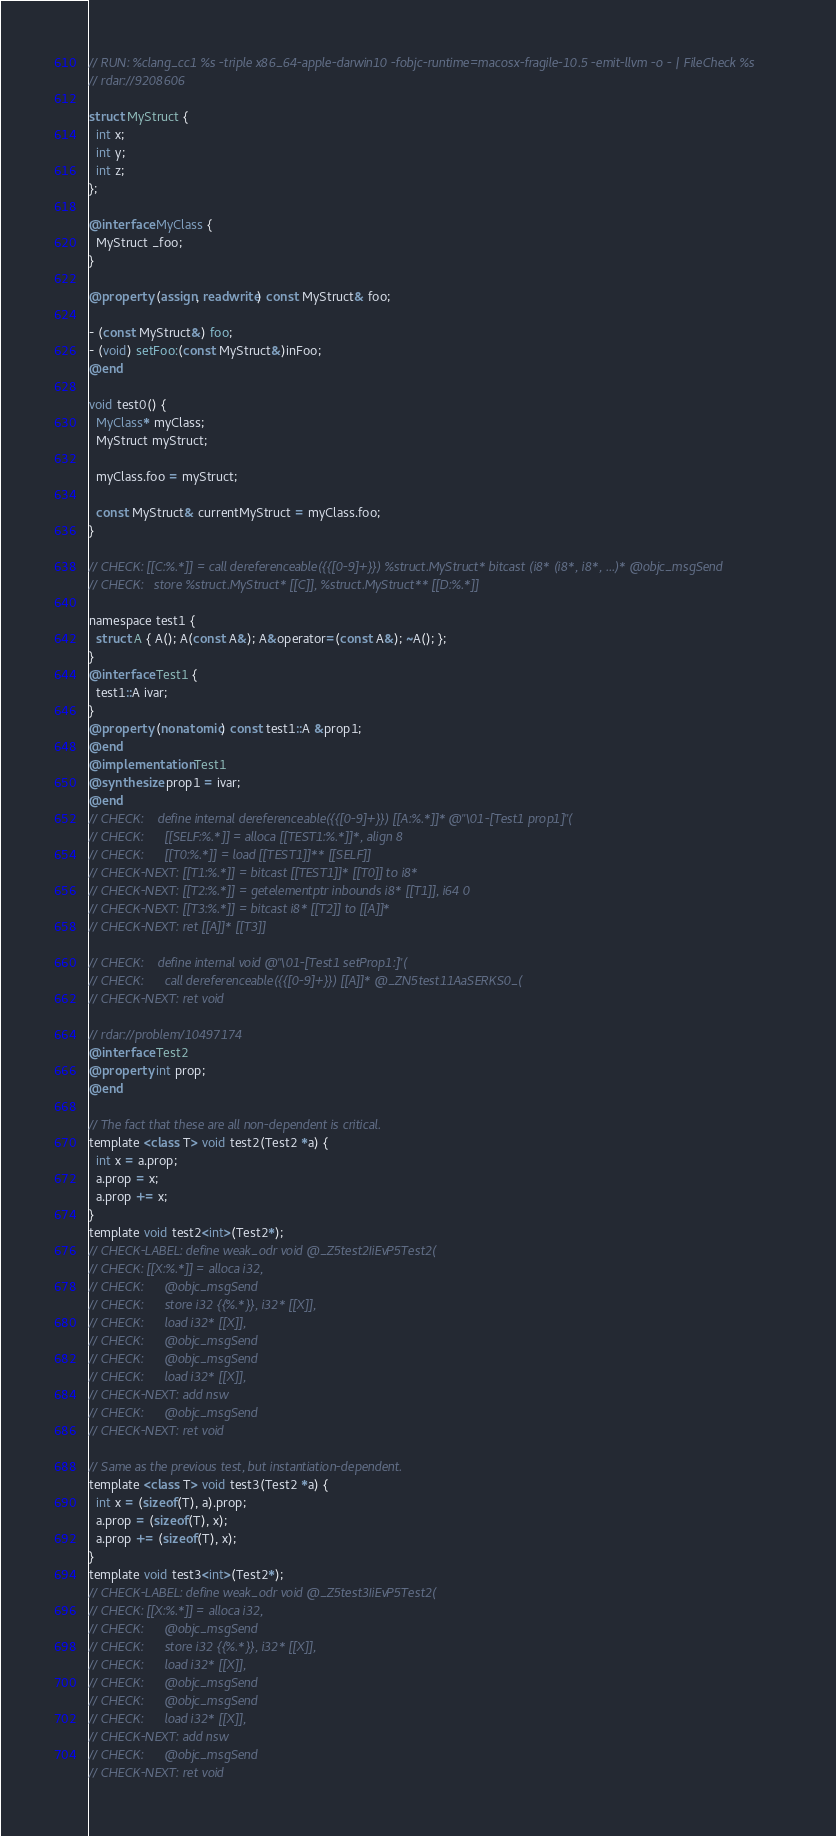<code> <loc_0><loc_0><loc_500><loc_500><_ObjectiveC_>// RUN: %clang_cc1 %s -triple x86_64-apple-darwin10 -fobjc-runtime=macosx-fragile-10.5 -emit-llvm -o - | FileCheck %s
// rdar://9208606

struct MyStruct {
  int x;
  int y;
  int z;
};

@interface MyClass {
  MyStruct _foo;
}

@property (assign, readwrite) const MyStruct& foo;

- (const MyStruct&) foo;
- (void) setFoo:(const MyStruct&)inFoo;
@end

void test0() {
  MyClass* myClass;
  MyStruct myStruct;

  myClass.foo = myStruct;

  const MyStruct& currentMyStruct = myClass.foo;   
}

// CHECK: [[C:%.*]] = call dereferenceable({{[0-9]+}}) %struct.MyStruct* bitcast (i8* (i8*, i8*, ...)* @objc_msgSend
// CHECK:   store %struct.MyStruct* [[C]], %struct.MyStruct** [[D:%.*]]

namespace test1 {
  struct A { A(); A(const A&); A&operator=(const A&); ~A(); };
}
@interface Test1 {
  test1::A ivar;
}
@property (nonatomic) const test1::A &prop1;
@end
@implementation Test1
@synthesize prop1 = ivar;
@end
// CHECK:    define internal dereferenceable({{[0-9]+}}) [[A:%.*]]* @"\01-[Test1 prop1]"(
// CHECK:      [[SELF:%.*]] = alloca [[TEST1:%.*]]*, align 8
// CHECK:      [[T0:%.*]] = load [[TEST1]]** [[SELF]]
// CHECK-NEXT: [[T1:%.*]] = bitcast [[TEST1]]* [[T0]] to i8*
// CHECK-NEXT: [[T2:%.*]] = getelementptr inbounds i8* [[T1]], i64 0
// CHECK-NEXT: [[T3:%.*]] = bitcast i8* [[T2]] to [[A]]*
// CHECK-NEXT: ret [[A]]* [[T3]]

// CHECK:    define internal void @"\01-[Test1 setProp1:]"(
// CHECK:      call dereferenceable({{[0-9]+}}) [[A]]* @_ZN5test11AaSERKS0_(
// CHECK-NEXT: ret void

// rdar://problem/10497174
@interface Test2
@property int prop;
@end

// The fact that these are all non-dependent is critical.
template <class T> void test2(Test2 *a) {
  int x = a.prop;
  a.prop = x;
  a.prop += x;
}
template void test2<int>(Test2*);
// CHECK-LABEL: define weak_odr void @_Z5test2IiEvP5Test2(
// CHECK: [[X:%.*]] = alloca i32,
// CHECK:      @objc_msgSend
// CHECK:      store i32 {{%.*}}, i32* [[X]],
// CHECK:      load i32* [[X]],
// CHECK:      @objc_msgSend
// CHECK:      @objc_msgSend
// CHECK:      load i32* [[X]],
// CHECK-NEXT: add nsw
// CHECK:      @objc_msgSend
// CHECK-NEXT: ret void

// Same as the previous test, but instantiation-dependent.
template <class T> void test3(Test2 *a) {
  int x = (sizeof(T), a).prop;
  a.prop = (sizeof(T), x);
  a.prop += (sizeof(T), x);
}
template void test3<int>(Test2*);
// CHECK-LABEL: define weak_odr void @_Z5test3IiEvP5Test2(
// CHECK: [[X:%.*]] = alloca i32,
// CHECK:      @objc_msgSend
// CHECK:      store i32 {{%.*}}, i32* [[X]],
// CHECK:      load i32* [[X]],
// CHECK:      @objc_msgSend
// CHECK:      @objc_msgSend
// CHECK:      load i32* [[X]],
// CHECK-NEXT: add nsw
// CHECK:      @objc_msgSend
// CHECK-NEXT: ret void
</code> 